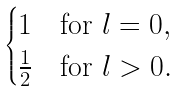Convert formula to latex. <formula><loc_0><loc_0><loc_500><loc_500>\begin{cases} 1 & \text {for } l = 0 , \\ \frac { 1 } { 2 } & \text {for } l > 0 . \end{cases}</formula> 